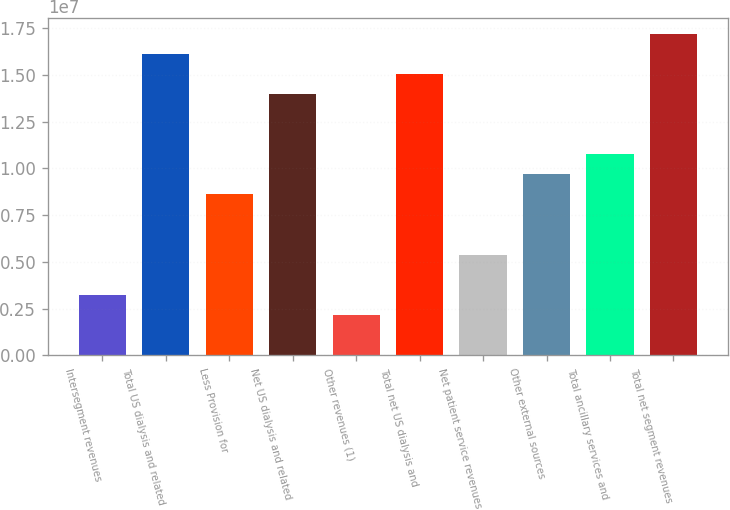Convert chart. <chart><loc_0><loc_0><loc_500><loc_500><bar_chart><fcel>Intersegment revenues<fcel>Total US dialysis and related<fcel>Less Provision for<fcel>Net US dialysis and related<fcel>Other revenues (1)<fcel>Total net US dialysis and<fcel>Net patient service revenues<fcel>Other external sources<fcel>Total ancillary services and<fcel>Total net segment revenues<nl><fcel>3.23313e+06<fcel>1.61356e+07<fcel>8.60915e+06<fcel>1.39852e+07<fcel>2.15792e+06<fcel>1.50604e+07<fcel>5.38354e+06<fcel>9.68436e+06<fcel>1.07596e+07<fcel>1.72108e+07<nl></chart> 